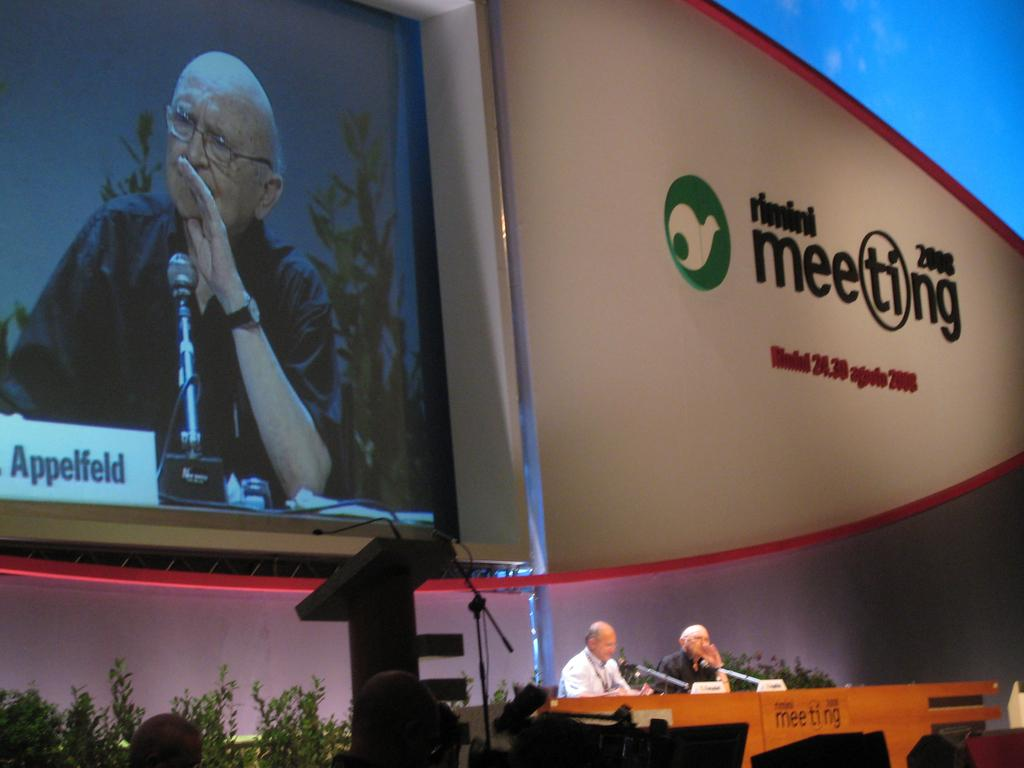<image>
Give a short and clear explanation of the subsequent image. a jumbo tron with a man on it named appelfeld 